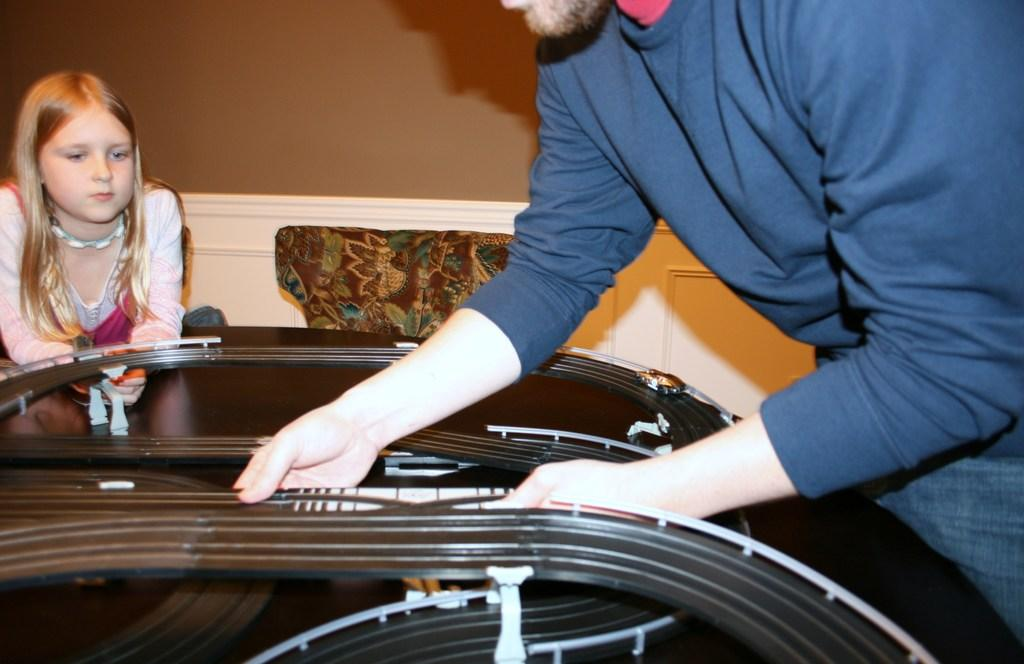What is the man doing in the image? The man is working with equipment in the image. Can you describe the girl's position in relation to the man? The girl is behind the equipment in the image. What can be seen in the background of the image? There is a wall in the background of the image. What type of skate is the girl using to communicate with the man in the image? There is no skate present in the image, and the girl is not using any device to communicate with the man. 